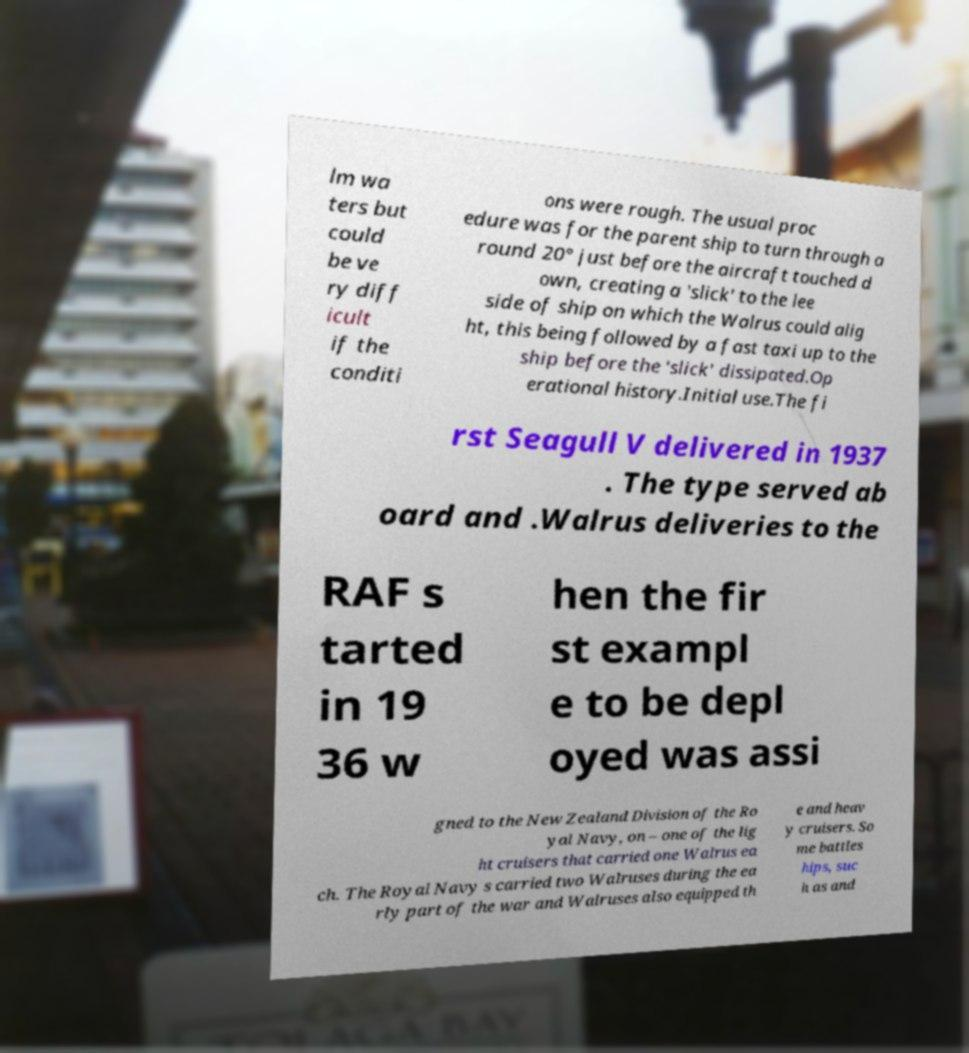What messages or text are displayed in this image? I need them in a readable, typed format. lm wa ters but could be ve ry diff icult if the conditi ons were rough. The usual proc edure was for the parent ship to turn through a round 20° just before the aircraft touched d own, creating a 'slick' to the lee side of ship on which the Walrus could alig ht, this being followed by a fast taxi up to the ship before the 'slick' dissipated.Op erational history.Initial use.The fi rst Seagull V delivered in 1937 . The type served ab oard and .Walrus deliveries to the RAF s tarted in 19 36 w hen the fir st exampl e to be depl oyed was assi gned to the New Zealand Division of the Ro yal Navy, on – one of the lig ht cruisers that carried one Walrus ea ch. The Royal Navy s carried two Walruses during the ea rly part of the war and Walruses also equipped th e and heav y cruisers. So me battles hips, suc h as and 